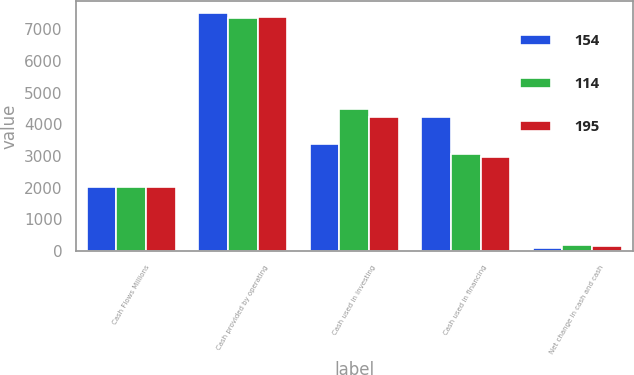<chart> <loc_0><loc_0><loc_500><loc_500><stacked_bar_chart><ecel><fcel>Cash Flows Millions<fcel>Cash provided by operating<fcel>Cash used in investing<fcel>Cash used in financing<fcel>Net change in cash and cash<nl><fcel>154<fcel>2016<fcel>7525<fcel>3393<fcel>4246<fcel>114<nl><fcel>114<fcel>2015<fcel>7344<fcel>4476<fcel>3063<fcel>195<nl><fcel>195<fcel>2014<fcel>7385<fcel>4249<fcel>2982<fcel>154<nl></chart> 